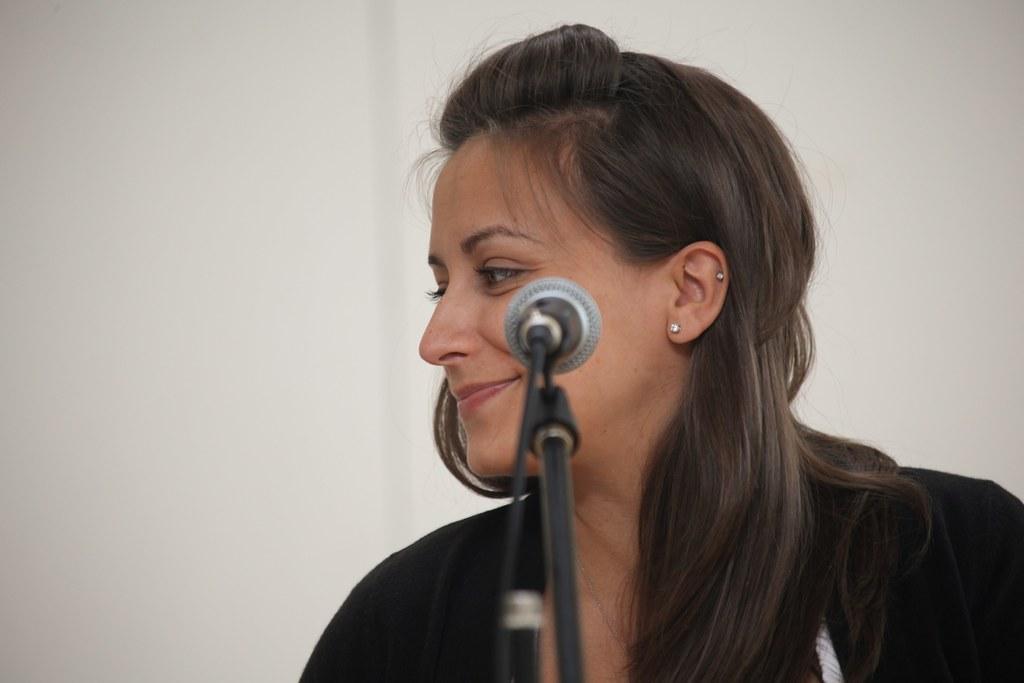Can you describe this image briefly? There is a lady with ear studs. In front of her there is a mic with mic stand. In the back there is a wall. 